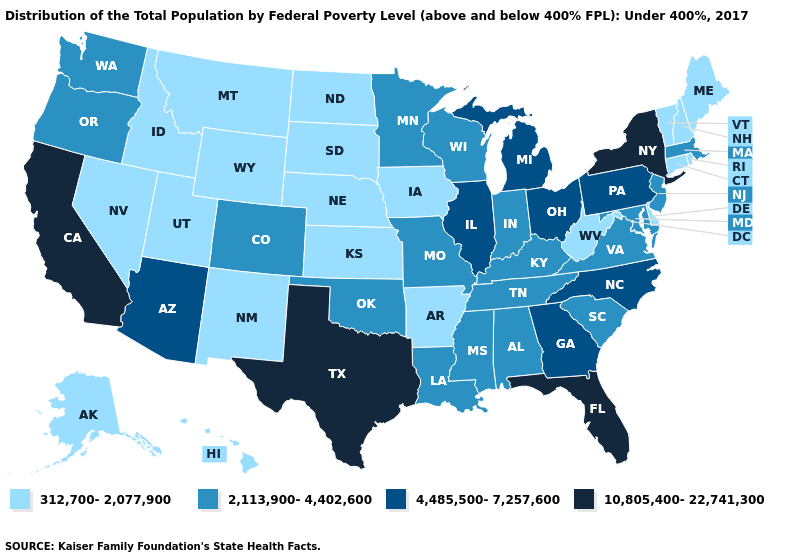Which states have the lowest value in the USA?
Concise answer only. Alaska, Arkansas, Connecticut, Delaware, Hawaii, Idaho, Iowa, Kansas, Maine, Montana, Nebraska, Nevada, New Hampshire, New Mexico, North Dakota, Rhode Island, South Dakota, Utah, Vermont, West Virginia, Wyoming. What is the lowest value in the USA?
Keep it brief. 312,700-2,077,900. What is the value of Arkansas?
Keep it brief. 312,700-2,077,900. Does the first symbol in the legend represent the smallest category?
Keep it brief. Yes. Name the states that have a value in the range 10,805,400-22,741,300?
Short answer required. California, Florida, New York, Texas. What is the lowest value in the South?
Short answer required. 312,700-2,077,900. Which states have the highest value in the USA?
Keep it brief. California, Florida, New York, Texas. Does New Hampshire have the same value as Ohio?
Keep it brief. No. Does the first symbol in the legend represent the smallest category?
Short answer required. Yes. What is the value of Alabama?
Give a very brief answer. 2,113,900-4,402,600. What is the value of Wisconsin?
Keep it brief. 2,113,900-4,402,600. Name the states that have a value in the range 4,485,500-7,257,600?
Short answer required. Arizona, Georgia, Illinois, Michigan, North Carolina, Ohio, Pennsylvania. What is the value of North Carolina?
Concise answer only. 4,485,500-7,257,600. Name the states that have a value in the range 10,805,400-22,741,300?
Be succinct. California, Florida, New York, Texas. Name the states that have a value in the range 2,113,900-4,402,600?
Short answer required. Alabama, Colorado, Indiana, Kentucky, Louisiana, Maryland, Massachusetts, Minnesota, Mississippi, Missouri, New Jersey, Oklahoma, Oregon, South Carolina, Tennessee, Virginia, Washington, Wisconsin. 